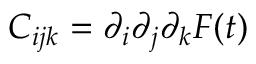<formula> <loc_0><loc_0><loc_500><loc_500>C _ { i j k } = \partial _ { i } \partial _ { j } \partial _ { k } F ( t )</formula> 